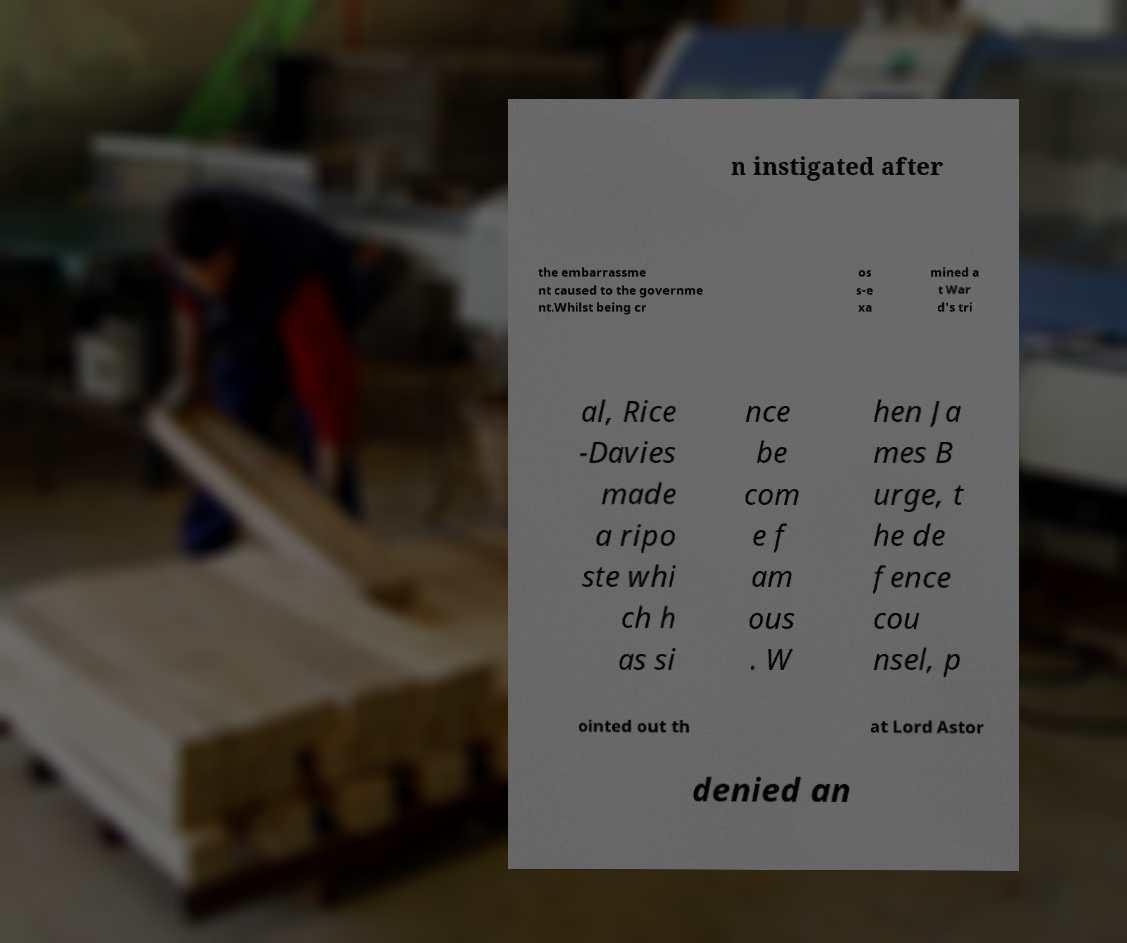Please read and relay the text visible in this image. What does it say? n instigated after the embarrassme nt caused to the governme nt.Whilst being cr os s-e xa mined a t War d's tri al, Rice -Davies made a ripo ste whi ch h as si nce be com e f am ous . W hen Ja mes B urge, t he de fence cou nsel, p ointed out th at Lord Astor denied an 